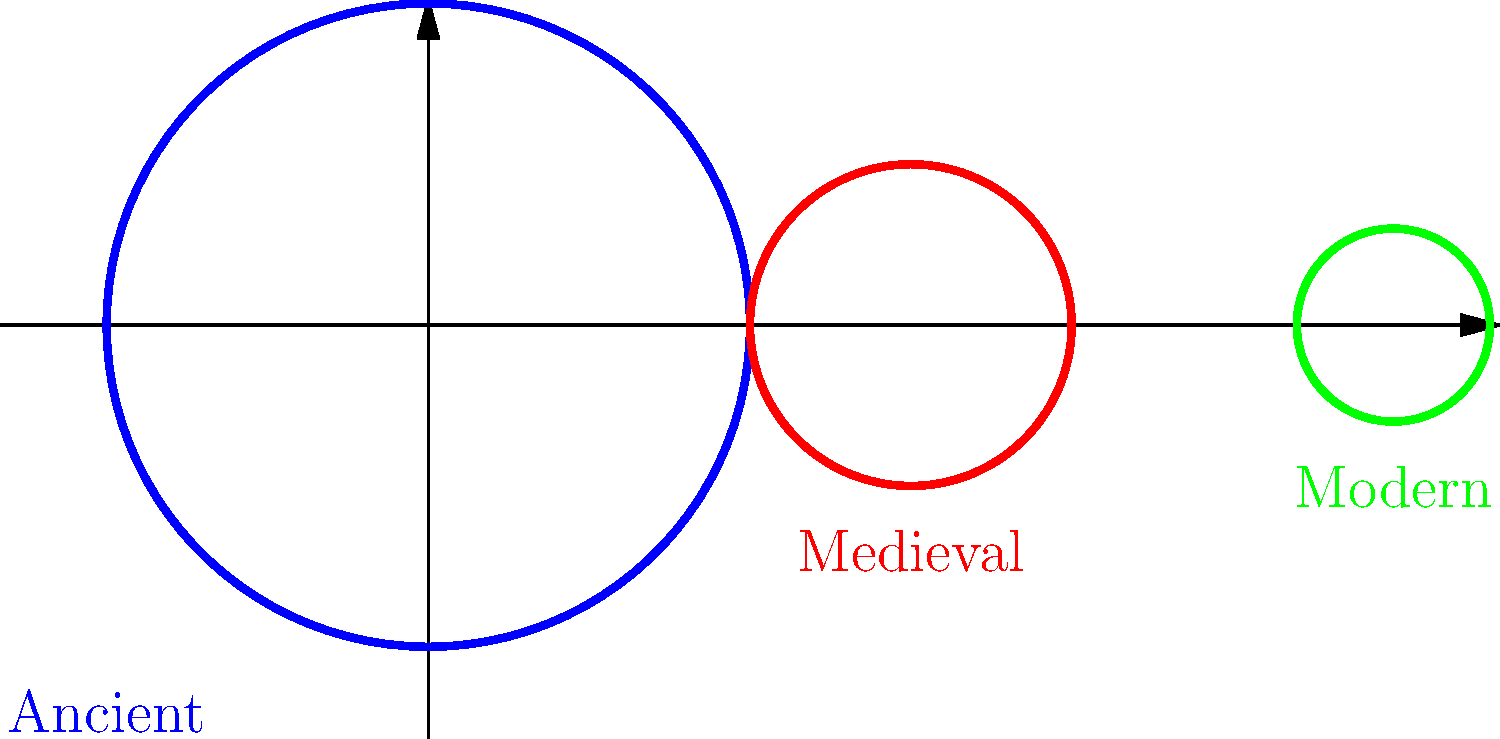Which shape represents the evolution of Jewish bread from ancient to modern times? 1. The graph shows three distinct shapes representing the evolution of Jewish bread:

   - Blue circle: Ancient times
   - Red oval: Medieval period
   - Green small circle: Modern era

2. Ancient Jewish bread (blue): The large circular shape represents flatbreads like matzah, which were common in ancient times. These were simple, unleavened breads made quickly.

3. Medieval Jewish bread (red): The oval shape represents the transition to more complex breads. This includes the development of challah, a braided bread that became popular in Eastern Europe during the Middle Ages.

4. Modern Jewish bread (green): The small circular shape represents the diversification and miniaturization of Jewish breads in modern times. This includes bagels, which became popular in the late 19th and early 20th centuries.

5. The progression from left to right (blue to red to green) shows the chronological evolution of Jewish bread shapes over time.

Therefore, the correct sequence representing the evolution of Jewish bread shapes from ancient to modern times is: Circle (blue) → Oval (red) → Small circle (green).
Answer: Circle → Oval → Small circle 